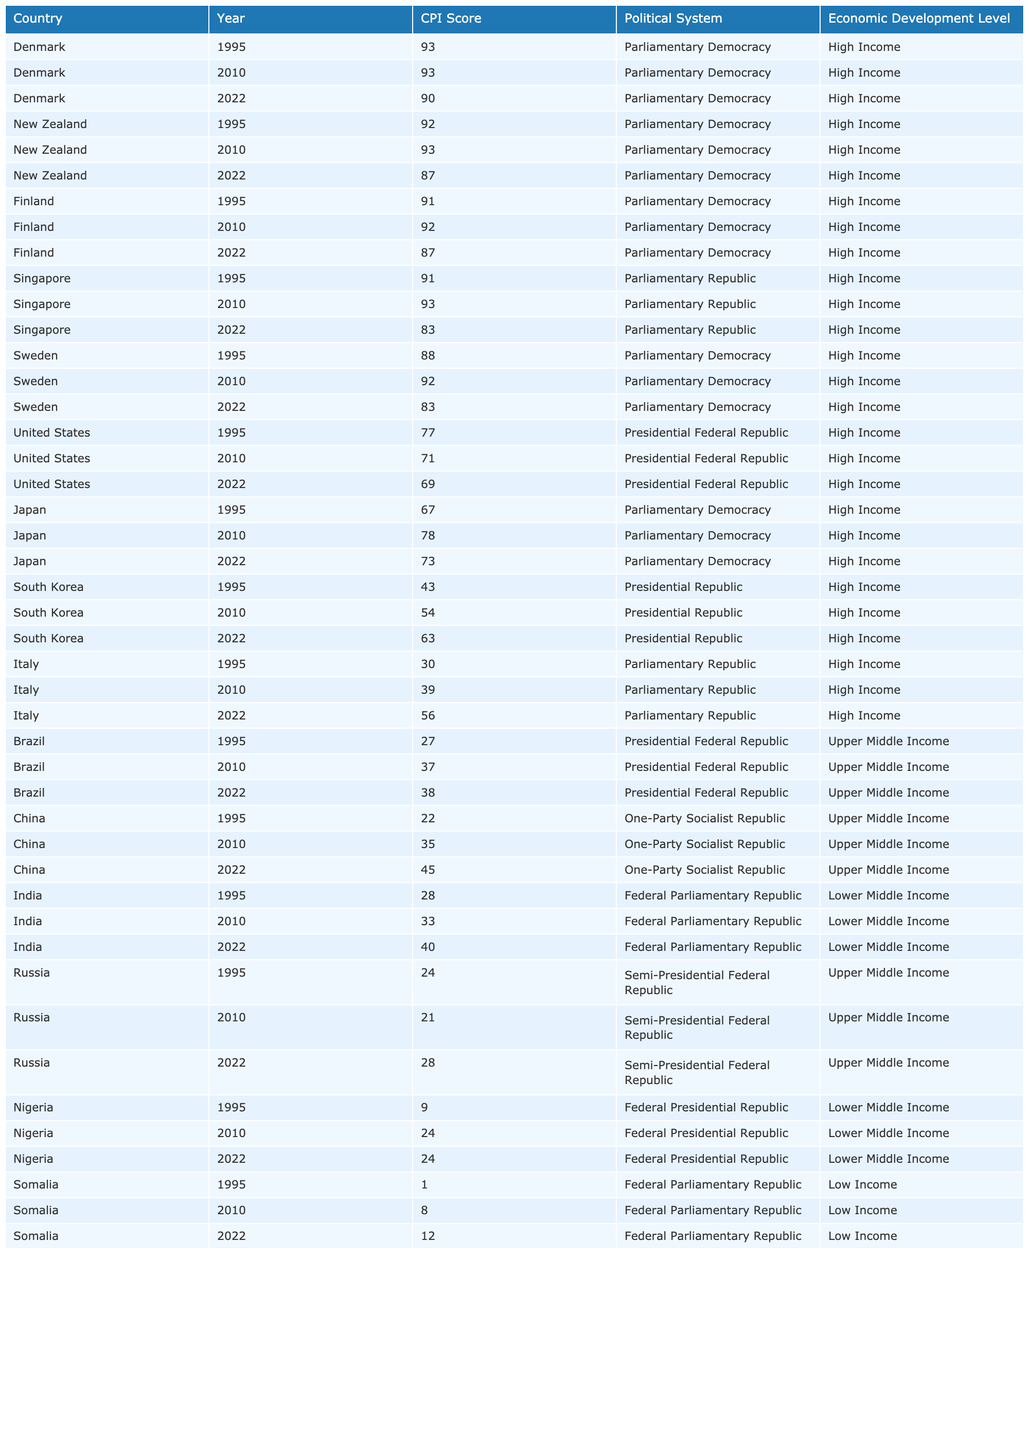What was the highest CPI score recorded for Denmark? In the table, Denmark's CPI scores across the years are 93 (1995), 93 (2010), and 90 (2022). The highest score is 93.
Answer: 93 What was the average CPI score for the United States between 1995 and 2022? The CPI scores for the United States are 77 (1995), 71 (2010), and 69 (2022). The average is (77 + 71 + 69) / 3 = 72.33, which rounds to 72.
Answer: 72 Did Singapore's CPI score decrease from 1995 to 2022? The CPI scores for Singapore are 91 (1995), 93 (2010), and 83 (2022). The last score is lower than the first score, indicating a decrease.
Answer: Yes Which country improved its CPI score the most from 1995 to 2022? Looking at the differences for each country: Italy (+26), China (+23), India (+12), and South Korea (+20). The significant improvement was from Italy, which had a score of 30 in 1995 and 56 in 2022.
Answer: Italy What was the lowest CPI score recorded across all countries in the dataset? The scores for Somalia are 1 (1995), 8 (2010), and 12 (2022), making 1 the lowest score recorded in the dataset.
Answer: 1 How many countries had a CPI score below 30 in 2022? The countries with scores below 30 in 2022 are Italy (56), Brazil (38), Nigeria (24), and Somalia (12). This counts to 4 countries below 30 in 2022.
Answer: 2 Which country showed a Continuous Decrease in CPI score between 1995 and 2022? By checking the CPI scores for Japan (67 to 73), Sweden (88 to 83), South Korea (43 to 63), and the US (77 to 69), only the US shows continuous decrease throughout the years; others fluctuated positively or showed increases on some years.
Answer: United States What is the relationship between economic development level and CPI scores for high-income countries? Evaluating high-income countries: Denmark (90), New Zealand (87), Finland (87), Sweden (83), and the US (69) indicate that generally high-income countries have CPI scores above 60, indicating less perceived corruption compared to others.
Answer: Positive relationship Which country had a CPI score in 2022 that was the closest to the world average for high-income countries? The average CPI score for high-income countries is around 81. The countries closest to this in 2022 were Finland (87) and Denmark (90). However, the closest within a margin would be the United States (69) since others are maybe 20-30 off.
Answer: United States What trend can be observed for Nigeria's CPI scores from 1995 to 2022? Nigeria's CPI scores were 9 (1995), 24 (2010), and 24 (2022). This shows a positive trend from 1995 to 2010, but stagnation from 2010 to 2022.
Answer: Mixed trend 